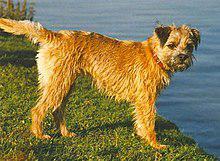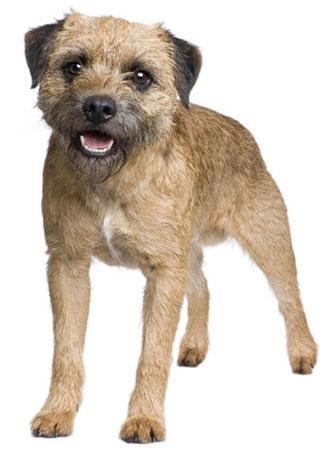The first image is the image on the left, the second image is the image on the right. For the images shown, is this caption "The right image contains one dog that is standing on grass." true? Answer yes or no. No. The first image is the image on the left, the second image is the image on the right. Given the left and right images, does the statement "A dog stands in profile on the grass with its tail extended." hold true? Answer yes or no. Yes. 